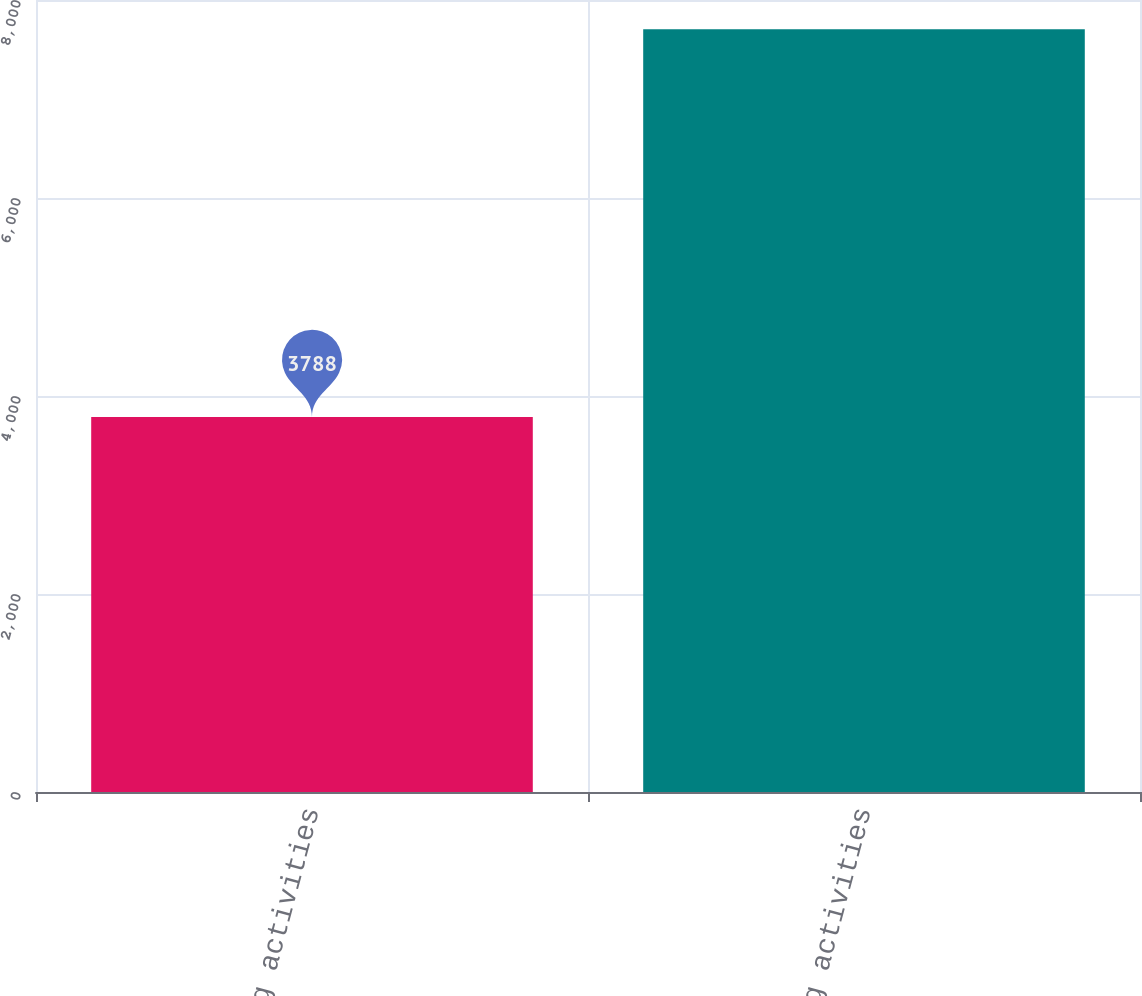<chart> <loc_0><loc_0><loc_500><loc_500><bar_chart><fcel>Investing activities<fcel>Financing activities<nl><fcel>3788<fcel>7705<nl></chart> 